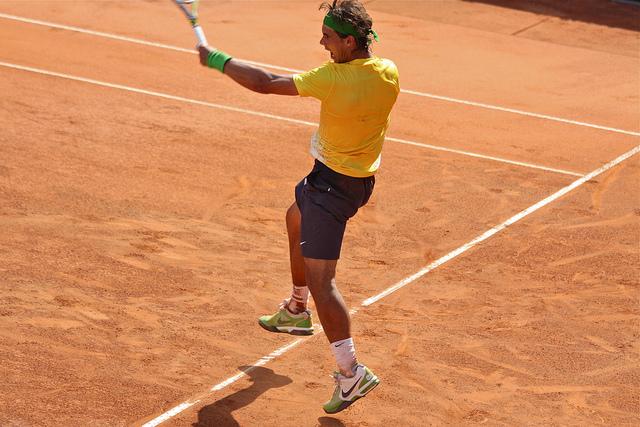What color is the man's shirt?
Short answer required. Yellow. What color is his shirt?
Give a very brief answer. Yellow. Are the man's feet on the ground?
Concise answer only. No. Can you see the person's head?
Answer briefly. Yes. Which game is the man playing?
Concise answer only. Tennis. 